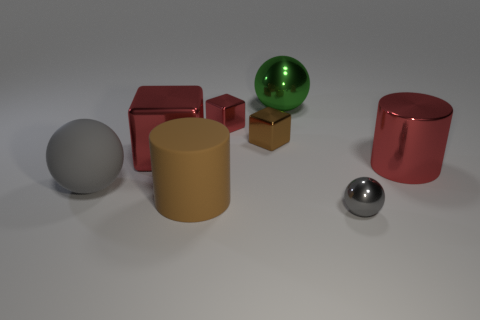What is the size of the matte object that is the same color as the small metallic ball?
Ensure brevity in your answer.  Large. Is there a tiny thing of the same color as the matte ball?
Provide a short and direct response. Yes. Do the big shiny block and the large cylinder that is on the right side of the big brown object have the same color?
Ensure brevity in your answer.  Yes. There is a metallic thing that is the same shape as the large brown rubber object; what is its color?
Provide a succinct answer. Red. Do the large metal thing on the right side of the tiny gray metal thing and the large metallic cube have the same color?
Your answer should be compact. Yes. How many other things are the same size as the green thing?
Your answer should be compact. 4. What number of brown objects are either cubes or large matte cylinders?
Provide a short and direct response. 2. How many shiny objects are behind the large brown matte cylinder and on the right side of the small brown shiny object?
Provide a succinct answer. 2. What is the material of the large cylinder left of the red cube behind the big red metal object to the left of the tiny gray shiny object?
Ensure brevity in your answer.  Rubber. How many large brown cylinders are made of the same material as the small red cube?
Provide a short and direct response. 0. 